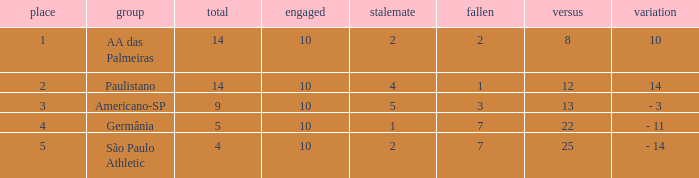What is the highest Drawn when the lost is 7 and the points are more than 4, and the against is less than 22? None. 